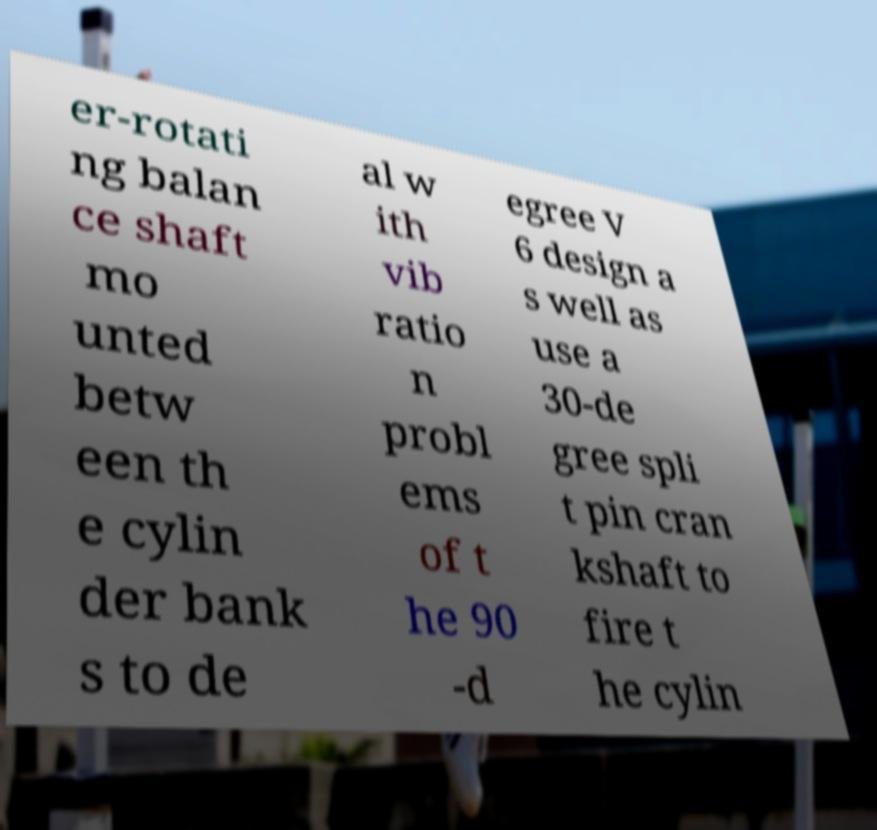Could you assist in decoding the text presented in this image and type it out clearly? er-rotati ng balan ce shaft mo unted betw een th e cylin der bank s to de al w ith vib ratio n probl ems of t he 90 -d egree V 6 design a s well as use a 30-de gree spli t pin cran kshaft to fire t he cylin 